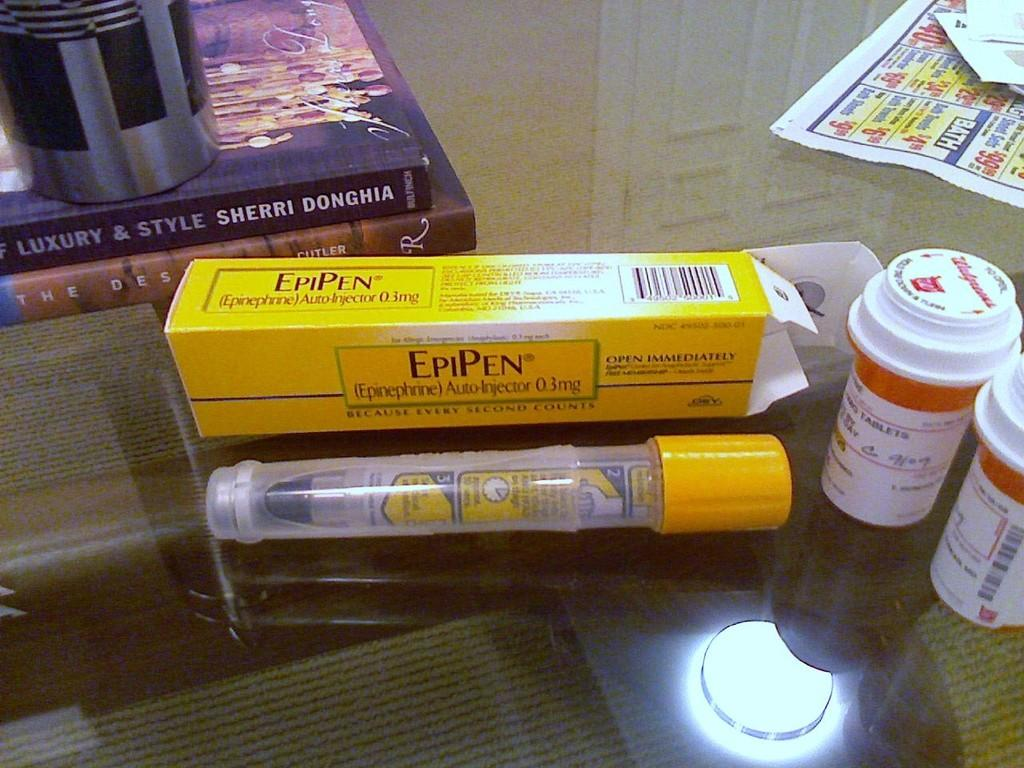<image>
Describe the image concisely. An EpiPen sitting on top of a glass table with an EpiPen box sitting behind it. 